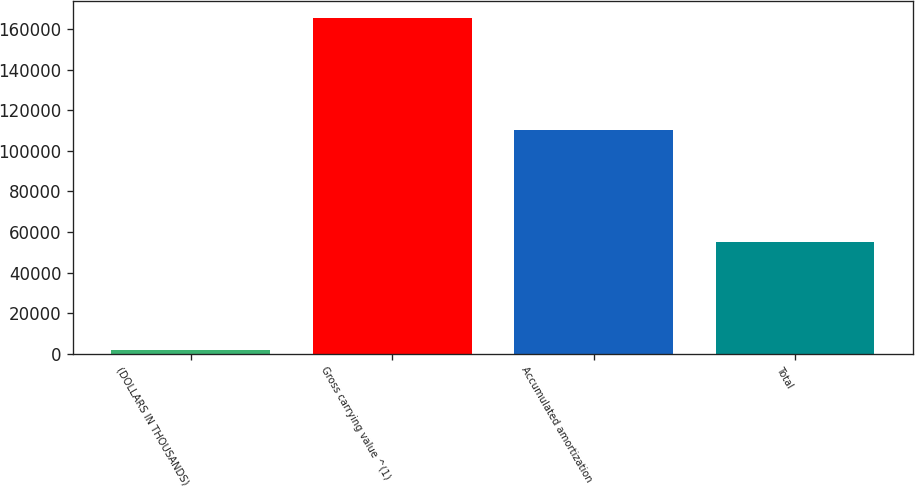Convert chart to OTSL. <chart><loc_0><loc_0><loc_500><loc_500><bar_chart><fcel>(DOLLARS IN THOUSANDS)<fcel>Gross carrying value ^(1)<fcel>Accumulated amortization<fcel>Total<nl><fcel>2009<fcel>165406<fcel>110458<fcel>54948<nl></chart> 